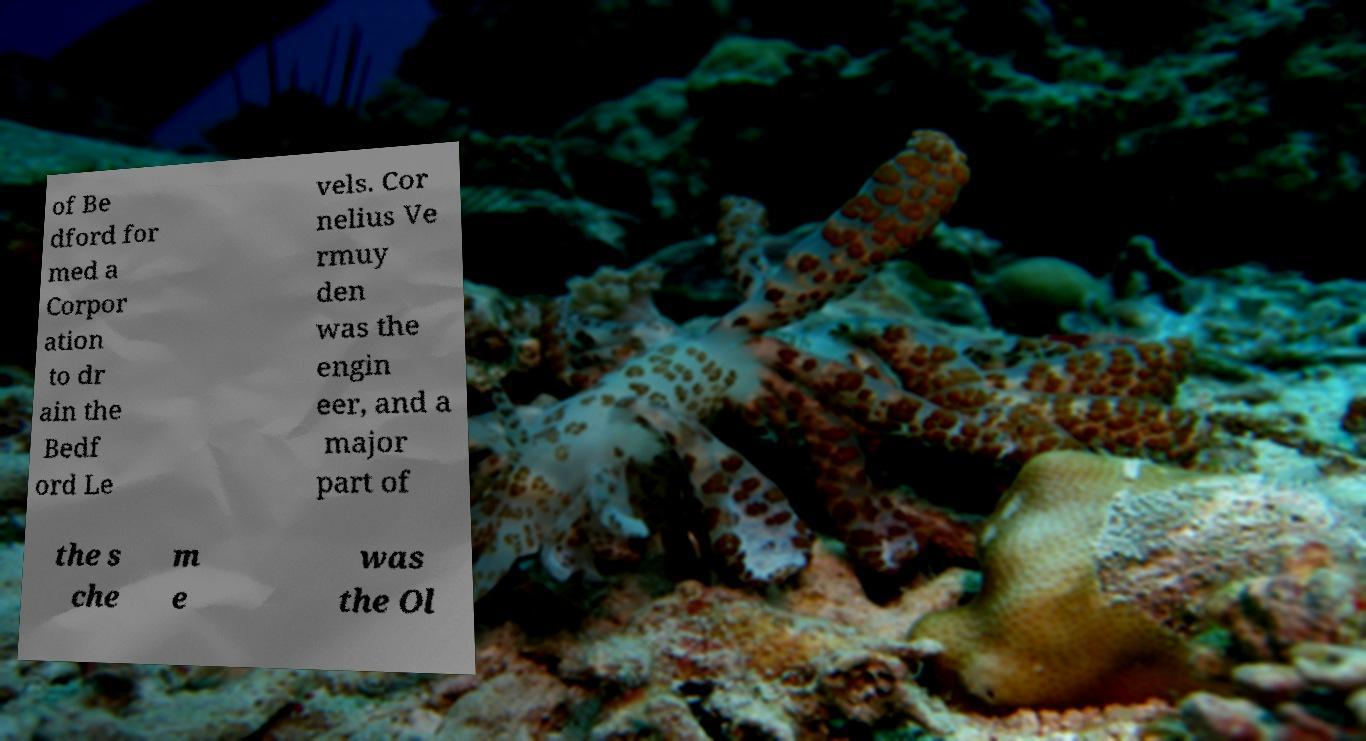Please identify and transcribe the text found in this image. of Be dford for med a Corpor ation to dr ain the Bedf ord Le vels. Cor nelius Ve rmuy den was the engin eer, and a major part of the s che m e was the Ol 